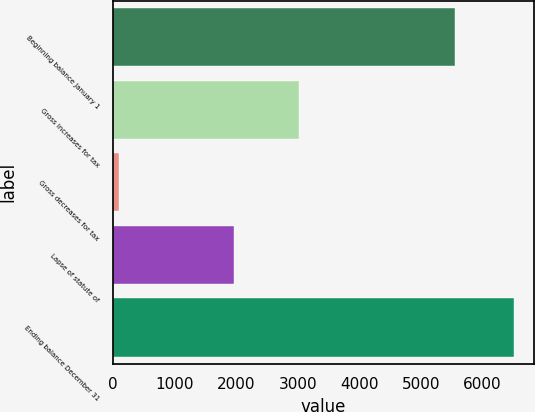<chart> <loc_0><loc_0><loc_500><loc_500><bar_chart><fcel>Beginning balance January 1<fcel>Gross increases for tax<fcel>Gross decreases for tax<fcel>Lapse of statute of<fcel>Ending balance December 31<nl><fcel>5548<fcel>3017<fcel>98<fcel>1961<fcel>6506<nl></chart> 